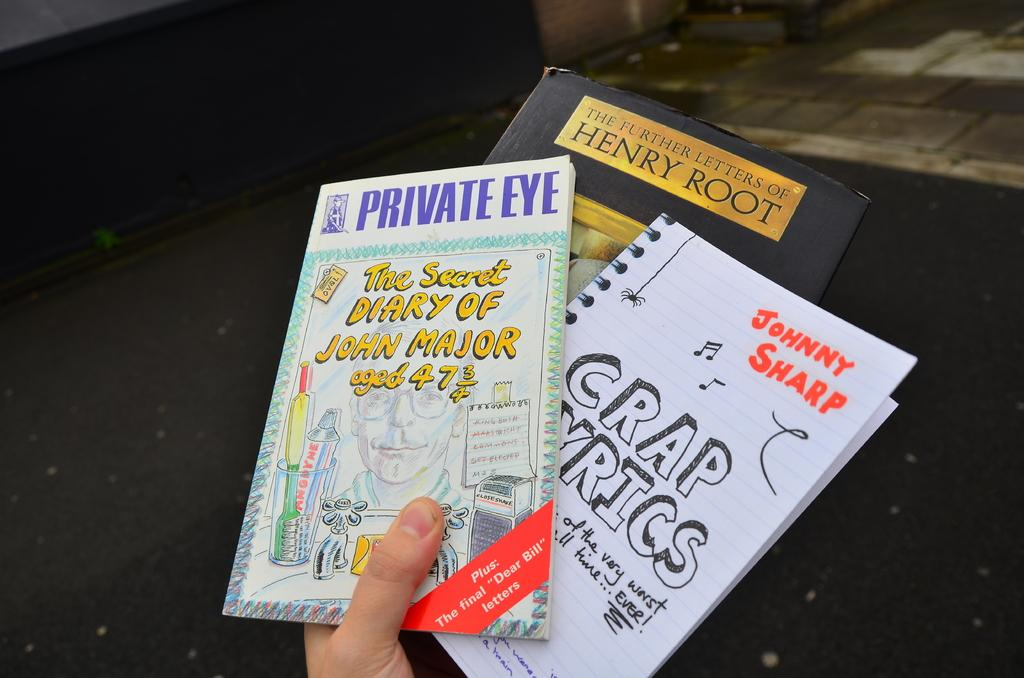<image>
Give a short and clear explanation of the subsequent image. Three books in someones hands with one of them titled 'the secret diary of john major 